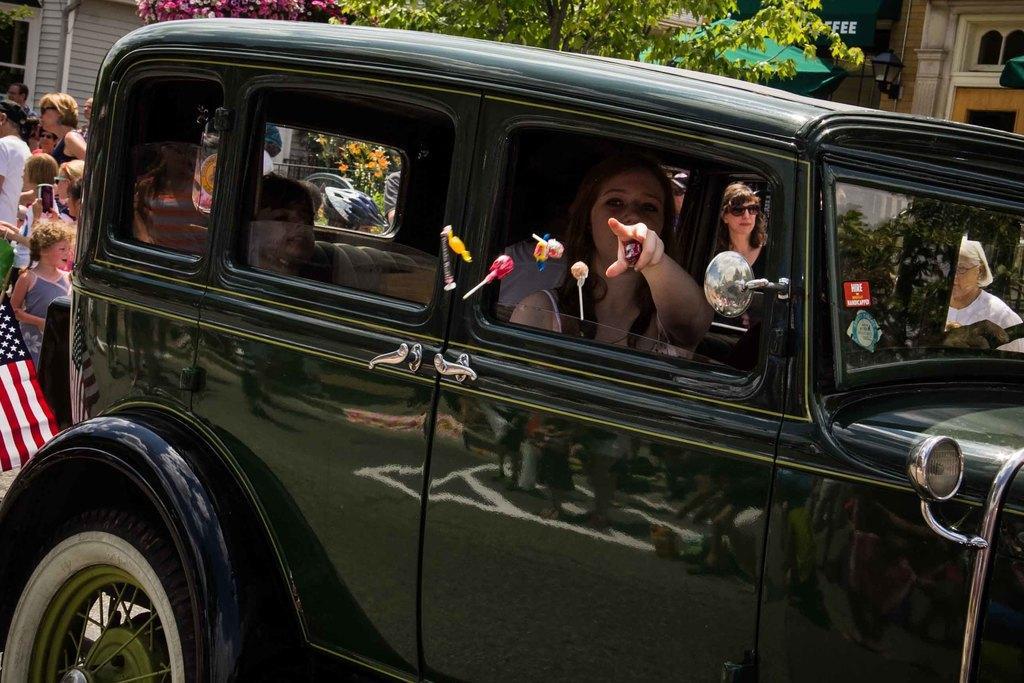Could you give a brief overview of what you see in this image? in the picture we can see a car ,in the car a lady is present inside the car there are many people walking,there are trees ,buildings and flag. 